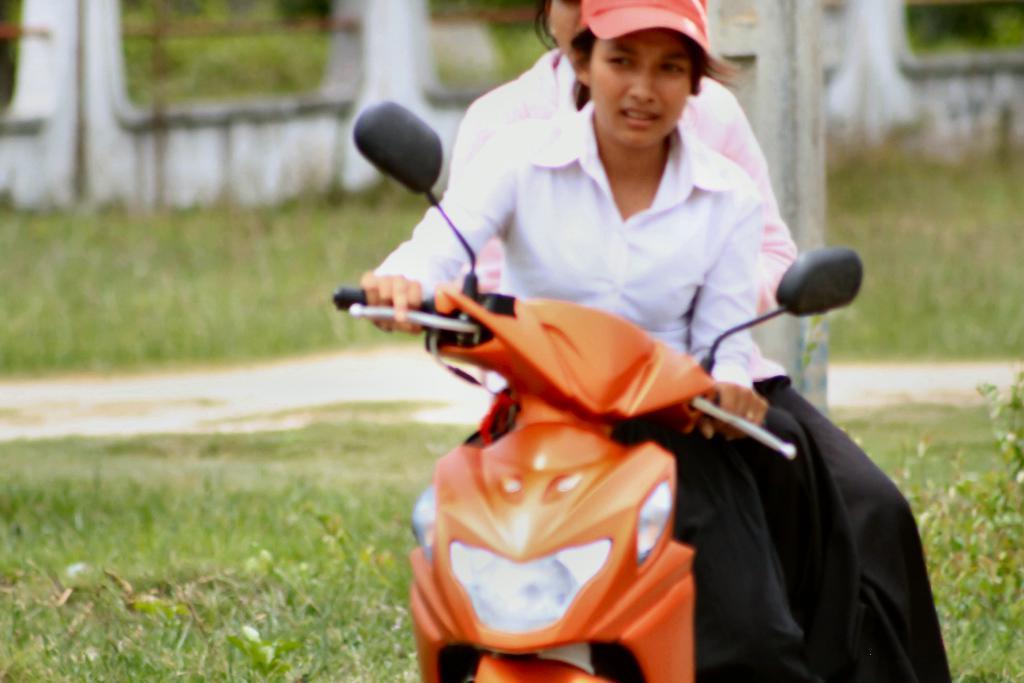Please provide a concise description of this image. In this image, I can see two persons sitting on a motorbike. In the background, I can see the grass, pole and a wall. 